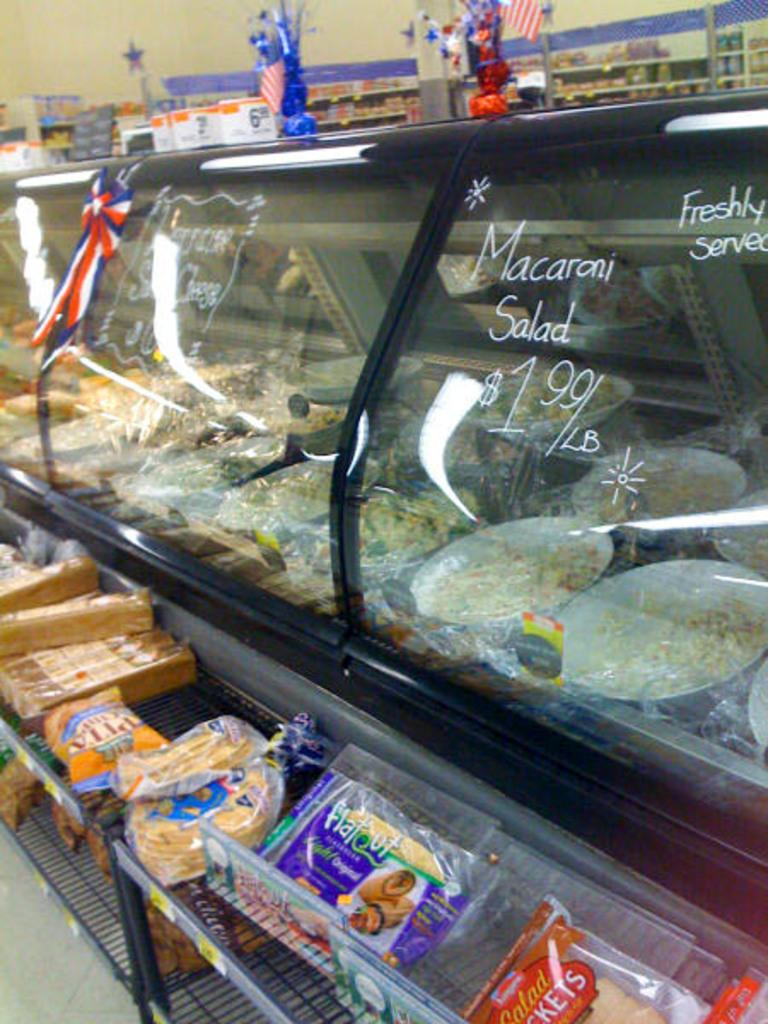<image>
Relay a brief, clear account of the picture shown. a deli display case with Macaroni Salad for $1.99/LB and other items for sale 